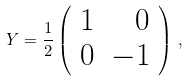Convert formula to latex. <formula><loc_0><loc_0><loc_500><loc_500>Y = \frac { 1 } { 2 } \left ( \begin{array} { r r } 1 & 0 \\ 0 & - 1 \end{array} \right ) \, ,</formula> 